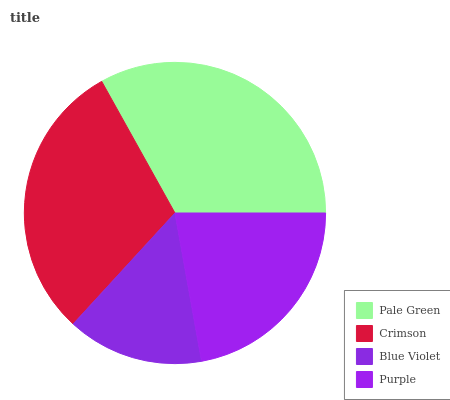Is Blue Violet the minimum?
Answer yes or no. Yes. Is Pale Green the maximum?
Answer yes or no. Yes. Is Crimson the minimum?
Answer yes or no. No. Is Crimson the maximum?
Answer yes or no. No. Is Pale Green greater than Crimson?
Answer yes or no. Yes. Is Crimson less than Pale Green?
Answer yes or no. Yes. Is Crimson greater than Pale Green?
Answer yes or no. No. Is Pale Green less than Crimson?
Answer yes or no. No. Is Crimson the high median?
Answer yes or no. Yes. Is Purple the low median?
Answer yes or no. Yes. Is Blue Violet the high median?
Answer yes or no. No. Is Pale Green the low median?
Answer yes or no. No. 